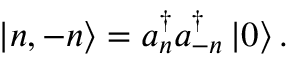<formula> <loc_0><loc_0><loc_500><loc_500>\left | n , - n \right \rangle = a _ { n } ^ { \dagger } a _ { - n } ^ { \dagger } \left | 0 \right \rangle .</formula> 